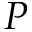<formula> <loc_0><loc_0><loc_500><loc_500>P</formula> 